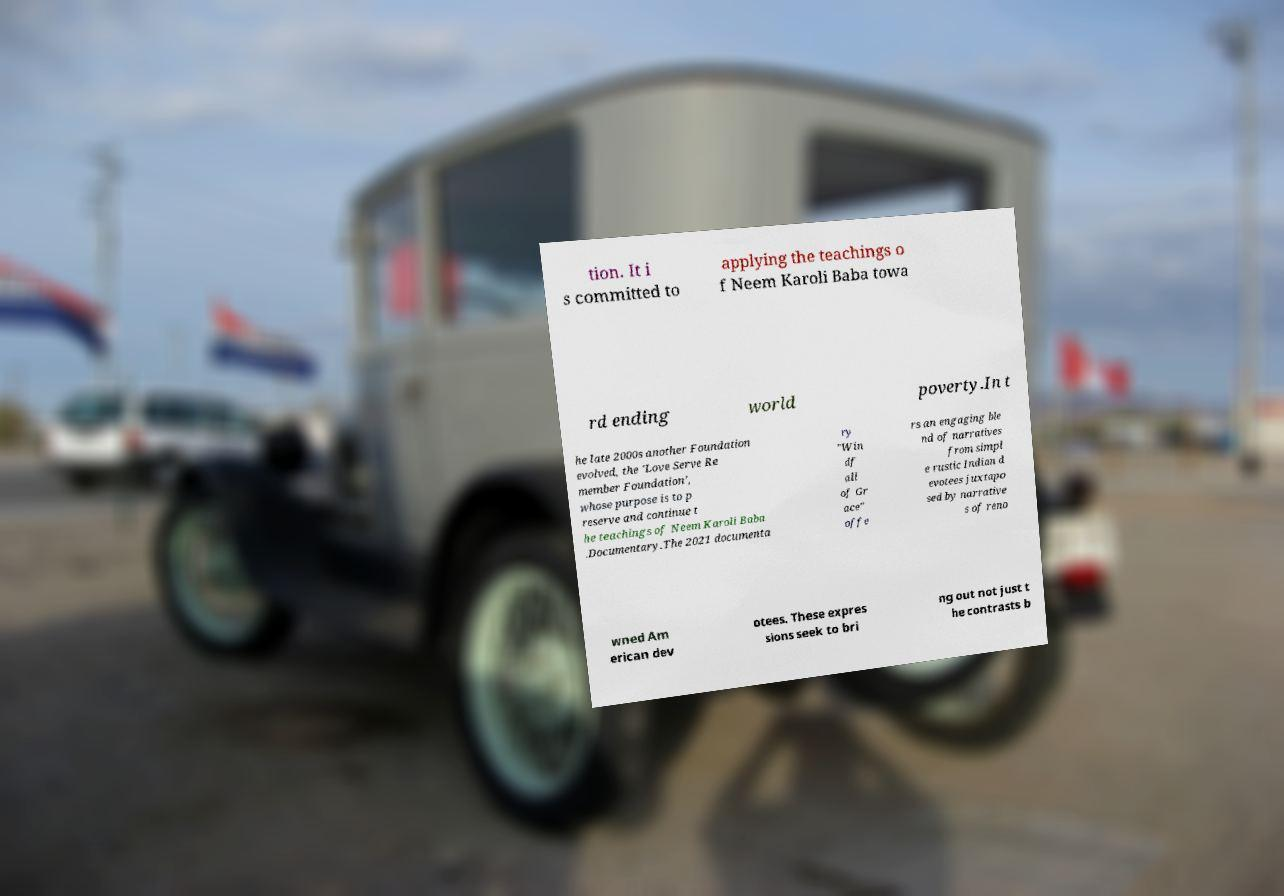Can you accurately transcribe the text from the provided image for me? tion. It i s committed to applying the teachings o f Neem Karoli Baba towa rd ending world poverty.In t he late 2000s another Foundation evolved, the 'Love Serve Re member Foundation', whose purpose is to p reserve and continue t he teachings of Neem Karoli Baba .Documentary.The 2021 documenta ry "Win df all of Gr ace" offe rs an engaging ble nd of narratives from simpl e rustic Indian d evotees juxtapo sed by narrative s of reno wned Am erican dev otees. These expres sions seek to bri ng out not just t he contrasts b 